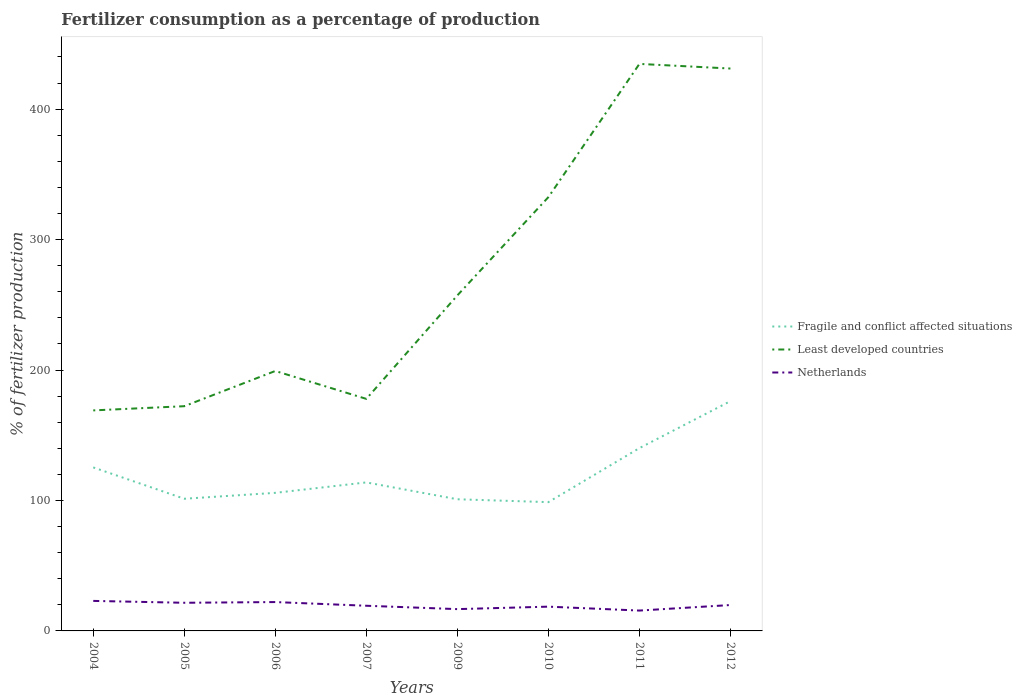Does the line corresponding to Least developed countries intersect with the line corresponding to Fragile and conflict affected situations?
Your answer should be compact. No. Is the number of lines equal to the number of legend labels?
Keep it short and to the point. Yes. Across all years, what is the maximum percentage of fertilizers consumed in Netherlands?
Give a very brief answer. 15.6. What is the total percentage of fertilizers consumed in Netherlands in the graph?
Offer a very short reply. -4.24. What is the difference between the highest and the second highest percentage of fertilizers consumed in Fragile and conflict affected situations?
Make the answer very short. 77.42. Is the percentage of fertilizers consumed in Fragile and conflict affected situations strictly greater than the percentage of fertilizers consumed in Netherlands over the years?
Provide a short and direct response. No. How many years are there in the graph?
Provide a short and direct response. 8. Does the graph contain grids?
Make the answer very short. No. Where does the legend appear in the graph?
Offer a very short reply. Center right. How many legend labels are there?
Keep it short and to the point. 3. How are the legend labels stacked?
Keep it short and to the point. Vertical. What is the title of the graph?
Make the answer very short. Fertilizer consumption as a percentage of production. Does "Norway" appear as one of the legend labels in the graph?
Your answer should be very brief. No. What is the label or title of the Y-axis?
Offer a terse response. % of fertilizer production. What is the % of fertilizer production of Fragile and conflict affected situations in 2004?
Give a very brief answer. 125.33. What is the % of fertilizer production of Least developed countries in 2004?
Give a very brief answer. 169.04. What is the % of fertilizer production of Netherlands in 2004?
Give a very brief answer. 23.01. What is the % of fertilizer production in Fragile and conflict affected situations in 2005?
Your answer should be very brief. 101.32. What is the % of fertilizer production of Least developed countries in 2005?
Ensure brevity in your answer.  172.25. What is the % of fertilizer production in Netherlands in 2005?
Give a very brief answer. 21.58. What is the % of fertilizer production of Fragile and conflict affected situations in 2006?
Keep it short and to the point. 105.84. What is the % of fertilizer production in Least developed countries in 2006?
Your response must be concise. 199.25. What is the % of fertilizer production in Netherlands in 2006?
Make the answer very short. 22.12. What is the % of fertilizer production of Fragile and conflict affected situations in 2007?
Your answer should be very brief. 113.84. What is the % of fertilizer production in Least developed countries in 2007?
Give a very brief answer. 177.87. What is the % of fertilizer production of Netherlands in 2007?
Offer a very short reply. 19.29. What is the % of fertilizer production of Fragile and conflict affected situations in 2009?
Ensure brevity in your answer.  100.93. What is the % of fertilizer production of Least developed countries in 2009?
Provide a short and direct response. 257.18. What is the % of fertilizer production in Netherlands in 2009?
Give a very brief answer. 16.71. What is the % of fertilizer production of Fragile and conflict affected situations in 2010?
Provide a succinct answer. 98.72. What is the % of fertilizer production in Least developed countries in 2010?
Your answer should be compact. 332.5. What is the % of fertilizer production in Netherlands in 2010?
Offer a very short reply. 18.6. What is the % of fertilizer production in Fragile and conflict affected situations in 2011?
Offer a very short reply. 140.13. What is the % of fertilizer production of Least developed countries in 2011?
Your answer should be very brief. 434.64. What is the % of fertilizer production of Netherlands in 2011?
Ensure brevity in your answer.  15.6. What is the % of fertilizer production in Fragile and conflict affected situations in 2012?
Your answer should be very brief. 176.14. What is the % of fertilizer production in Least developed countries in 2012?
Provide a succinct answer. 431.09. What is the % of fertilizer production of Netherlands in 2012?
Keep it short and to the point. 19.84. Across all years, what is the maximum % of fertilizer production in Fragile and conflict affected situations?
Provide a succinct answer. 176.14. Across all years, what is the maximum % of fertilizer production in Least developed countries?
Keep it short and to the point. 434.64. Across all years, what is the maximum % of fertilizer production of Netherlands?
Your response must be concise. 23.01. Across all years, what is the minimum % of fertilizer production of Fragile and conflict affected situations?
Your answer should be very brief. 98.72. Across all years, what is the minimum % of fertilizer production in Least developed countries?
Ensure brevity in your answer.  169.04. Across all years, what is the minimum % of fertilizer production in Netherlands?
Make the answer very short. 15.6. What is the total % of fertilizer production of Fragile and conflict affected situations in the graph?
Give a very brief answer. 962.24. What is the total % of fertilizer production of Least developed countries in the graph?
Ensure brevity in your answer.  2173.81. What is the total % of fertilizer production of Netherlands in the graph?
Provide a short and direct response. 156.76. What is the difference between the % of fertilizer production in Fragile and conflict affected situations in 2004 and that in 2005?
Make the answer very short. 24.02. What is the difference between the % of fertilizer production in Least developed countries in 2004 and that in 2005?
Provide a succinct answer. -3.22. What is the difference between the % of fertilizer production in Netherlands in 2004 and that in 2005?
Keep it short and to the point. 1.43. What is the difference between the % of fertilizer production of Fragile and conflict affected situations in 2004 and that in 2006?
Offer a very short reply. 19.5. What is the difference between the % of fertilizer production of Least developed countries in 2004 and that in 2006?
Offer a terse response. -30.21. What is the difference between the % of fertilizer production of Netherlands in 2004 and that in 2006?
Provide a succinct answer. 0.89. What is the difference between the % of fertilizer production in Fragile and conflict affected situations in 2004 and that in 2007?
Provide a short and direct response. 11.49. What is the difference between the % of fertilizer production in Least developed countries in 2004 and that in 2007?
Ensure brevity in your answer.  -8.83. What is the difference between the % of fertilizer production in Netherlands in 2004 and that in 2007?
Give a very brief answer. 3.71. What is the difference between the % of fertilizer production of Fragile and conflict affected situations in 2004 and that in 2009?
Offer a very short reply. 24.41. What is the difference between the % of fertilizer production of Least developed countries in 2004 and that in 2009?
Keep it short and to the point. -88.14. What is the difference between the % of fertilizer production in Netherlands in 2004 and that in 2009?
Provide a succinct answer. 6.3. What is the difference between the % of fertilizer production of Fragile and conflict affected situations in 2004 and that in 2010?
Provide a short and direct response. 26.61. What is the difference between the % of fertilizer production in Least developed countries in 2004 and that in 2010?
Give a very brief answer. -163.46. What is the difference between the % of fertilizer production of Netherlands in 2004 and that in 2010?
Provide a succinct answer. 4.41. What is the difference between the % of fertilizer production in Fragile and conflict affected situations in 2004 and that in 2011?
Your response must be concise. -14.8. What is the difference between the % of fertilizer production in Least developed countries in 2004 and that in 2011?
Offer a terse response. -265.6. What is the difference between the % of fertilizer production in Netherlands in 2004 and that in 2011?
Provide a succinct answer. 7.4. What is the difference between the % of fertilizer production in Fragile and conflict affected situations in 2004 and that in 2012?
Give a very brief answer. -50.8. What is the difference between the % of fertilizer production of Least developed countries in 2004 and that in 2012?
Make the answer very short. -262.05. What is the difference between the % of fertilizer production of Netherlands in 2004 and that in 2012?
Ensure brevity in your answer.  3.16. What is the difference between the % of fertilizer production of Fragile and conflict affected situations in 2005 and that in 2006?
Offer a very short reply. -4.52. What is the difference between the % of fertilizer production in Least developed countries in 2005 and that in 2006?
Your answer should be very brief. -27. What is the difference between the % of fertilizer production of Netherlands in 2005 and that in 2006?
Keep it short and to the point. -0.54. What is the difference between the % of fertilizer production in Fragile and conflict affected situations in 2005 and that in 2007?
Ensure brevity in your answer.  -12.53. What is the difference between the % of fertilizer production of Least developed countries in 2005 and that in 2007?
Your response must be concise. -5.62. What is the difference between the % of fertilizer production in Netherlands in 2005 and that in 2007?
Give a very brief answer. 2.28. What is the difference between the % of fertilizer production of Fragile and conflict affected situations in 2005 and that in 2009?
Make the answer very short. 0.39. What is the difference between the % of fertilizer production of Least developed countries in 2005 and that in 2009?
Offer a terse response. -84.93. What is the difference between the % of fertilizer production of Netherlands in 2005 and that in 2009?
Your response must be concise. 4.87. What is the difference between the % of fertilizer production in Fragile and conflict affected situations in 2005 and that in 2010?
Make the answer very short. 2.6. What is the difference between the % of fertilizer production in Least developed countries in 2005 and that in 2010?
Offer a very short reply. -160.24. What is the difference between the % of fertilizer production in Netherlands in 2005 and that in 2010?
Keep it short and to the point. 2.97. What is the difference between the % of fertilizer production in Fragile and conflict affected situations in 2005 and that in 2011?
Offer a very short reply. -38.81. What is the difference between the % of fertilizer production of Least developed countries in 2005 and that in 2011?
Provide a succinct answer. -262.38. What is the difference between the % of fertilizer production of Netherlands in 2005 and that in 2011?
Ensure brevity in your answer.  5.97. What is the difference between the % of fertilizer production in Fragile and conflict affected situations in 2005 and that in 2012?
Offer a very short reply. -74.82. What is the difference between the % of fertilizer production of Least developed countries in 2005 and that in 2012?
Make the answer very short. -258.83. What is the difference between the % of fertilizer production of Netherlands in 2005 and that in 2012?
Ensure brevity in your answer.  1.73. What is the difference between the % of fertilizer production of Fragile and conflict affected situations in 2006 and that in 2007?
Keep it short and to the point. -8. What is the difference between the % of fertilizer production in Least developed countries in 2006 and that in 2007?
Offer a very short reply. 21.38. What is the difference between the % of fertilizer production in Netherlands in 2006 and that in 2007?
Offer a very short reply. 2.83. What is the difference between the % of fertilizer production of Fragile and conflict affected situations in 2006 and that in 2009?
Make the answer very short. 4.91. What is the difference between the % of fertilizer production of Least developed countries in 2006 and that in 2009?
Offer a very short reply. -57.93. What is the difference between the % of fertilizer production of Netherlands in 2006 and that in 2009?
Provide a short and direct response. 5.41. What is the difference between the % of fertilizer production of Fragile and conflict affected situations in 2006 and that in 2010?
Your response must be concise. 7.12. What is the difference between the % of fertilizer production of Least developed countries in 2006 and that in 2010?
Keep it short and to the point. -133.25. What is the difference between the % of fertilizer production of Netherlands in 2006 and that in 2010?
Provide a succinct answer. 3.52. What is the difference between the % of fertilizer production in Fragile and conflict affected situations in 2006 and that in 2011?
Give a very brief answer. -34.29. What is the difference between the % of fertilizer production in Least developed countries in 2006 and that in 2011?
Make the answer very short. -235.39. What is the difference between the % of fertilizer production in Netherlands in 2006 and that in 2011?
Offer a terse response. 6.51. What is the difference between the % of fertilizer production of Fragile and conflict affected situations in 2006 and that in 2012?
Offer a terse response. -70.3. What is the difference between the % of fertilizer production in Least developed countries in 2006 and that in 2012?
Your answer should be very brief. -231.84. What is the difference between the % of fertilizer production of Netherlands in 2006 and that in 2012?
Your response must be concise. 2.28. What is the difference between the % of fertilizer production of Fragile and conflict affected situations in 2007 and that in 2009?
Your answer should be compact. 12.91. What is the difference between the % of fertilizer production in Least developed countries in 2007 and that in 2009?
Offer a very short reply. -79.31. What is the difference between the % of fertilizer production of Netherlands in 2007 and that in 2009?
Give a very brief answer. 2.58. What is the difference between the % of fertilizer production in Fragile and conflict affected situations in 2007 and that in 2010?
Ensure brevity in your answer.  15.12. What is the difference between the % of fertilizer production of Least developed countries in 2007 and that in 2010?
Keep it short and to the point. -154.63. What is the difference between the % of fertilizer production of Netherlands in 2007 and that in 2010?
Your answer should be very brief. 0.69. What is the difference between the % of fertilizer production in Fragile and conflict affected situations in 2007 and that in 2011?
Your response must be concise. -26.29. What is the difference between the % of fertilizer production in Least developed countries in 2007 and that in 2011?
Keep it short and to the point. -256.76. What is the difference between the % of fertilizer production in Netherlands in 2007 and that in 2011?
Give a very brief answer. 3.69. What is the difference between the % of fertilizer production in Fragile and conflict affected situations in 2007 and that in 2012?
Your answer should be compact. -62.29. What is the difference between the % of fertilizer production in Least developed countries in 2007 and that in 2012?
Offer a terse response. -253.22. What is the difference between the % of fertilizer production in Netherlands in 2007 and that in 2012?
Your answer should be very brief. -0.55. What is the difference between the % of fertilizer production of Fragile and conflict affected situations in 2009 and that in 2010?
Offer a terse response. 2.21. What is the difference between the % of fertilizer production of Least developed countries in 2009 and that in 2010?
Your response must be concise. -75.32. What is the difference between the % of fertilizer production in Netherlands in 2009 and that in 2010?
Offer a terse response. -1.89. What is the difference between the % of fertilizer production in Fragile and conflict affected situations in 2009 and that in 2011?
Give a very brief answer. -39.2. What is the difference between the % of fertilizer production of Least developed countries in 2009 and that in 2011?
Offer a terse response. -177.45. What is the difference between the % of fertilizer production of Netherlands in 2009 and that in 2011?
Give a very brief answer. 1.1. What is the difference between the % of fertilizer production in Fragile and conflict affected situations in 2009 and that in 2012?
Give a very brief answer. -75.21. What is the difference between the % of fertilizer production of Least developed countries in 2009 and that in 2012?
Ensure brevity in your answer.  -173.91. What is the difference between the % of fertilizer production in Netherlands in 2009 and that in 2012?
Provide a short and direct response. -3.14. What is the difference between the % of fertilizer production in Fragile and conflict affected situations in 2010 and that in 2011?
Provide a short and direct response. -41.41. What is the difference between the % of fertilizer production in Least developed countries in 2010 and that in 2011?
Provide a short and direct response. -102.14. What is the difference between the % of fertilizer production of Netherlands in 2010 and that in 2011?
Your answer should be compact. 3. What is the difference between the % of fertilizer production of Fragile and conflict affected situations in 2010 and that in 2012?
Ensure brevity in your answer.  -77.42. What is the difference between the % of fertilizer production in Least developed countries in 2010 and that in 2012?
Provide a succinct answer. -98.59. What is the difference between the % of fertilizer production in Netherlands in 2010 and that in 2012?
Your answer should be compact. -1.24. What is the difference between the % of fertilizer production in Fragile and conflict affected situations in 2011 and that in 2012?
Your answer should be very brief. -36.01. What is the difference between the % of fertilizer production of Least developed countries in 2011 and that in 2012?
Make the answer very short. 3.55. What is the difference between the % of fertilizer production in Netherlands in 2011 and that in 2012?
Your answer should be very brief. -4.24. What is the difference between the % of fertilizer production in Fragile and conflict affected situations in 2004 and the % of fertilizer production in Least developed countries in 2005?
Offer a terse response. -46.92. What is the difference between the % of fertilizer production in Fragile and conflict affected situations in 2004 and the % of fertilizer production in Netherlands in 2005?
Give a very brief answer. 103.76. What is the difference between the % of fertilizer production in Least developed countries in 2004 and the % of fertilizer production in Netherlands in 2005?
Provide a succinct answer. 147.46. What is the difference between the % of fertilizer production in Fragile and conflict affected situations in 2004 and the % of fertilizer production in Least developed countries in 2006?
Ensure brevity in your answer.  -73.92. What is the difference between the % of fertilizer production of Fragile and conflict affected situations in 2004 and the % of fertilizer production of Netherlands in 2006?
Your answer should be compact. 103.22. What is the difference between the % of fertilizer production of Least developed countries in 2004 and the % of fertilizer production of Netherlands in 2006?
Your response must be concise. 146.92. What is the difference between the % of fertilizer production of Fragile and conflict affected situations in 2004 and the % of fertilizer production of Least developed countries in 2007?
Provide a short and direct response. -52.54. What is the difference between the % of fertilizer production of Fragile and conflict affected situations in 2004 and the % of fertilizer production of Netherlands in 2007?
Give a very brief answer. 106.04. What is the difference between the % of fertilizer production of Least developed countries in 2004 and the % of fertilizer production of Netherlands in 2007?
Offer a very short reply. 149.74. What is the difference between the % of fertilizer production of Fragile and conflict affected situations in 2004 and the % of fertilizer production of Least developed countries in 2009?
Offer a terse response. -131.85. What is the difference between the % of fertilizer production in Fragile and conflict affected situations in 2004 and the % of fertilizer production in Netherlands in 2009?
Keep it short and to the point. 108.63. What is the difference between the % of fertilizer production of Least developed countries in 2004 and the % of fertilizer production of Netherlands in 2009?
Offer a very short reply. 152.33. What is the difference between the % of fertilizer production in Fragile and conflict affected situations in 2004 and the % of fertilizer production in Least developed countries in 2010?
Your response must be concise. -207.16. What is the difference between the % of fertilizer production in Fragile and conflict affected situations in 2004 and the % of fertilizer production in Netherlands in 2010?
Keep it short and to the point. 106.73. What is the difference between the % of fertilizer production of Least developed countries in 2004 and the % of fertilizer production of Netherlands in 2010?
Your answer should be compact. 150.44. What is the difference between the % of fertilizer production of Fragile and conflict affected situations in 2004 and the % of fertilizer production of Least developed countries in 2011?
Your response must be concise. -309.3. What is the difference between the % of fertilizer production of Fragile and conflict affected situations in 2004 and the % of fertilizer production of Netherlands in 2011?
Provide a short and direct response. 109.73. What is the difference between the % of fertilizer production in Least developed countries in 2004 and the % of fertilizer production in Netherlands in 2011?
Make the answer very short. 153.43. What is the difference between the % of fertilizer production of Fragile and conflict affected situations in 2004 and the % of fertilizer production of Least developed countries in 2012?
Your answer should be very brief. -305.75. What is the difference between the % of fertilizer production in Fragile and conflict affected situations in 2004 and the % of fertilizer production in Netherlands in 2012?
Give a very brief answer. 105.49. What is the difference between the % of fertilizer production in Least developed countries in 2004 and the % of fertilizer production in Netherlands in 2012?
Give a very brief answer. 149.19. What is the difference between the % of fertilizer production in Fragile and conflict affected situations in 2005 and the % of fertilizer production in Least developed countries in 2006?
Keep it short and to the point. -97.93. What is the difference between the % of fertilizer production of Fragile and conflict affected situations in 2005 and the % of fertilizer production of Netherlands in 2006?
Give a very brief answer. 79.2. What is the difference between the % of fertilizer production in Least developed countries in 2005 and the % of fertilizer production in Netherlands in 2006?
Offer a very short reply. 150.14. What is the difference between the % of fertilizer production of Fragile and conflict affected situations in 2005 and the % of fertilizer production of Least developed countries in 2007?
Give a very brief answer. -76.56. What is the difference between the % of fertilizer production of Fragile and conflict affected situations in 2005 and the % of fertilizer production of Netherlands in 2007?
Offer a very short reply. 82.02. What is the difference between the % of fertilizer production of Least developed countries in 2005 and the % of fertilizer production of Netherlands in 2007?
Your answer should be compact. 152.96. What is the difference between the % of fertilizer production in Fragile and conflict affected situations in 2005 and the % of fertilizer production in Least developed countries in 2009?
Keep it short and to the point. -155.87. What is the difference between the % of fertilizer production of Fragile and conflict affected situations in 2005 and the % of fertilizer production of Netherlands in 2009?
Provide a succinct answer. 84.61. What is the difference between the % of fertilizer production in Least developed countries in 2005 and the % of fertilizer production in Netherlands in 2009?
Your answer should be very brief. 155.55. What is the difference between the % of fertilizer production of Fragile and conflict affected situations in 2005 and the % of fertilizer production of Least developed countries in 2010?
Provide a succinct answer. -231.18. What is the difference between the % of fertilizer production in Fragile and conflict affected situations in 2005 and the % of fertilizer production in Netherlands in 2010?
Your answer should be compact. 82.71. What is the difference between the % of fertilizer production of Least developed countries in 2005 and the % of fertilizer production of Netherlands in 2010?
Offer a terse response. 153.65. What is the difference between the % of fertilizer production in Fragile and conflict affected situations in 2005 and the % of fertilizer production in Least developed countries in 2011?
Your answer should be compact. -333.32. What is the difference between the % of fertilizer production of Fragile and conflict affected situations in 2005 and the % of fertilizer production of Netherlands in 2011?
Provide a succinct answer. 85.71. What is the difference between the % of fertilizer production in Least developed countries in 2005 and the % of fertilizer production in Netherlands in 2011?
Make the answer very short. 156.65. What is the difference between the % of fertilizer production in Fragile and conflict affected situations in 2005 and the % of fertilizer production in Least developed countries in 2012?
Ensure brevity in your answer.  -329.77. What is the difference between the % of fertilizer production in Fragile and conflict affected situations in 2005 and the % of fertilizer production in Netherlands in 2012?
Your response must be concise. 81.47. What is the difference between the % of fertilizer production of Least developed countries in 2005 and the % of fertilizer production of Netherlands in 2012?
Ensure brevity in your answer.  152.41. What is the difference between the % of fertilizer production of Fragile and conflict affected situations in 2006 and the % of fertilizer production of Least developed countries in 2007?
Keep it short and to the point. -72.03. What is the difference between the % of fertilizer production in Fragile and conflict affected situations in 2006 and the % of fertilizer production in Netherlands in 2007?
Your response must be concise. 86.55. What is the difference between the % of fertilizer production in Least developed countries in 2006 and the % of fertilizer production in Netherlands in 2007?
Your answer should be compact. 179.96. What is the difference between the % of fertilizer production of Fragile and conflict affected situations in 2006 and the % of fertilizer production of Least developed countries in 2009?
Keep it short and to the point. -151.34. What is the difference between the % of fertilizer production in Fragile and conflict affected situations in 2006 and the % of fertilizer production in Netherlands in 2009?
Keep it short and to the point. 89.13. What is the difference between the % of fertilizer production of Least developed countries in 2006 and the % of fertilizer production of Netherlands in 2009?
Give a very brief answer. 182.54. What is the difference between the % of fertilizer production of Fragile and conflict affected situations in 2006 and the % of fertilizer production of Least developed countries in 2010?
Offer a terse response. -226.66. What is the difference between the % of fertilizer production in Fragile and conflict affected situations in 2006 and the % of fertilizer production in Netherlands in 2010?
Your response must be concise. 87.24. What is the difference between the % of fertilizer production in Least developed countries in 2006 and the % of fertilizer production in Netherlands in 2010?
Your answer should be very brief. 180.65. What is the difference between the % of fertilizer production in Fragile and conflict affected situations in 2006 and the % of fertilizer production in Least developed countries in 2011?
Offer a very short reply. -328.8. What is the difference between the % of fertilizer production in Fragile and conflict affected situations in 2006 and the % of fertilizer production in Netherlands in 2011?
Provide a short and direct response. 90.24. What is the difference between the % of fertilizer production of Least developed countries in 2006 and the % of fertilizer production of Netherlands in 2011?
Provide a succinct answer. 183.65. What is the difference between the % of fertilizer production in Fragile and conflict affected situations in 2006 and the % of fertilizer production in Least developed countries in 2012?
Your response must be concise. -325.25. What is the difference between the % of fertilizer production in Fragile and conflict affected situations in 2006 and the % of fertilizer production in Netherlands in 2012?
Give a very brief answer. 86. What is the difference between the % of fertilizer production in Least developed countries in 2006 and the % of fertilizer production in Netherlands in 2012?
Offer a terse response. 179.41. What is the difference between the % of fertilizer production of Fragile and conflict affected situations in 2007 and the % of fertilizer production of Least developed countries in 2009?
Provide a short and direct response. -143.34. What is the difference between the % of fertilizer production in Fragile and conflict affected situations in 2007 and the % of fertilizer production in Netherlands in 2009?
Ensure brevity in your answer.  97.13. What is the difference between the % of fertilizer production in Least developed countries in 2007 and the % of fertilizer production in Netherlands in 2009?
Provide a short and direct response. 161.16. What is the difference between the % of fertilizer production of Fragile and conflict affected situations in 2007 and the % of fertilizer production of Least developed countries in 2010?
Make the answer very short. -218.66. What is the difference between the % of fertilizer production in Fragile and conflict affected situations in 2007 and the % of fertilizer production in Netherlands in 2010?
Offer a terse response. 95.24. What is the difference between the % of fertilizer production in Least developed countries in 2007 and the % of fertilizer production in Netherlands in 2010?
Provide a short and direct response. 159.27. What is the difference between the % of fertilizer production in Fragile and conflict affected situations in 2007 and the % of fertilizer production in Least developed countries in 2011?
Provide a succinct answer. -320.79. What is the difference between the % of fertilizer production in Fragile and conflict affected situations in 2007 and the % of fertilizer production in Netherlands in 2011?
Your answer should be very brief. 98.24. What is the difference between the % of fertilizer production of Least developed countries in 2007 and the % of fertilizer production of Netherlands in 2011?
Your answer should be compact. 162.27. What is the difference between the % of fertilizer production in Fragile and conflict affected situations in 2007 and the % of fertilizer production in Least developed countries in 2012?
Your answer should be compact. -317.25. What is the difference between the % of fertilizer production of Fragile and conflict affected situations in 2007 and the % of fertilizer production of Netherlands in 2012?
Your answer should be very brief. 94. What is the difference between the % of fertilizer production of Least developed countries in 2007 and the % of fertilizer production of Netherlands in 2012?
Your answer should be compact. 158.03. What is the difference between the % of fertilizer production in Fragile and conflict affected situations in 2009 and the % of fertilizer production in Least developed countries in 2010?
Keep it short and to the point. -231.57. What is the difference between the % of fertilizer production in Fragile and conflict affected situations in 2009 and the % of fertilizer production in Netherlands in 2010?
Your answer should be compact. 82.33. What is the difference between the % of fertilizer production in Least developed countries in 2009 and the % of fertilizer production in Netherlands in 2010?
Provide a short and direct response. 238.58. What is the difference between the % of fertilizer production in Fragile and conflict affected situations in 2009 and the % of fertilizer production in Least developed countries in 2011?
Provide a short and direct response. -333.71. What is the difference between the % of fertilizer production in Fragile and conflict affected situations in 2009 and the % of fertilizer production in Netherlands in 2011?
Your answer should be compact. 85.32. What is the difference between the % of fertilizer production in Least developed countries in 2009 and the % of fertilizer production in Netherlands in 2011?
Offer a terse response. 241.58. What is the difference between the % of fertilizer production of Fragile and conflict affected situations in 2009 and the % of fertilizer production of Least developed countries in 2012?
Provide a succinct answer. -330.16. What is the difference between the % of fertilizer production of Fragile and conflict affected situations in 2009 and the % of fertilizer production of Netherlands in 2012?
Give a very brief answer. 81.08. What is the difference between the % of fertilizer production in Least developed countries in 2009 and the % of fertilizer production in Netherlands in 2012?
Offer a terse response. 237.34. What is the difference between the % of fertilizer production of Fragile and conflict affected situations in 2010 and the % of fertilizer production of Least developed countries in 2011?
Offer a very short reply. -335.91. What is the difference between the % of fertilizer production of Fragile and conflict affected situations in 2010 and the % of fertilizer production of Netherlands in 2011?
Provide a short and direct response. 83.12. What is the difference between the % of fertilizer production of Least developed countries in 2010 and the % of fertilizer production of Netherlands in 2011?
Your answer should be compact. 316.89. What is the difference between the % of fertilizer production in Fragile and conflict affected situations in 2010 and the % of fertilizer production in Least developed countries in 2012?
Ensure brevity in your answer.  -332.37. What is the difference between the % of fertilizer production in Fragile and conflict affected situations in 2010 and the % of fertilizer production in Netherlands in 2012?
Keep it short and to the point. 78.88. What is the difference between the % of fertilizer production of Least developed countries in 2010 and the % of fertilizer production of Netherlands in 2012?
Your response must be concise. 312.65. What is the difference between the % of fertilizer production of Fragile and conflict affected situations in 2011 and the % of fertilizer production of Least developed countries in 2012?
Your answer should be very brief. -290.96. What is the difference between the % of fertilizer production of Fragile and conflict affected situations in 2011 and the % of fertilizer production of Netherlands in 2012?
Provide a succinct answer. 120.29. What is the difference between the % of fertilizer production in Least developed countries in 2011 and the % of fertilizer production in Netherlands in 2012?
Keep it short and to the point. 414.79. What is the average % of fertilizer production in Fragile and conflict affected situations per year?
Provide a succinct answer. 120.28. What is the average % of fertilizer production of Least developed countries per year?
Offer a very short reply. 271.73. What is the average % of fertilizer production in Netherlands per year?
Your answer should be compact. 19.59. In the year 2004, what is the difference between the % of fertilizer production in Fragile and conflict affected situations and % of fertilizer production in Least developed countries?
Offer a terse response. -43.7. In the year 2004, what is the difference between the % of fertilizer production of Fragile and conflict affected situations and % of fertilizer production of Netherlands?
Provide a short and direct response. 102.33. In the year 2004, what is the difference between the % of fertilizer production in Least developed countries and % of fertilizer production in Netherlands?
Give a very brief answer. 146.03. In the year 2005, what is the difference between the % of fertilizer production of Fragile and conflict affected situations and % of fertilizer production of Least developed countries?
Your answer should be compact. -70.94. In the year 2005, what is the difference between the % of fertilizer production in Fragile and conflict affected situations and % of fertilizer production in Netherlands?
Your answer should be compact. 79.74. In the year 2005, what is the difference between the % of fertilizer production in Least developed countries and % of fertilizer production in Netherlands?
Provide a short and direct response. 150.68. In the year 2006, what is the difference between the % of fertilizer production in Fragile and conflict affected situations and % of fertilizer production in Least developed countries?
Offer a terse response. -93.41. In the year 2006, what is the difference between the % of fertilizer production of Fragile and conflict affected situations and % of fertilizer production of Netherlands?
Offer a very short reply. 83.72. In the year 2006, what is the difference between the % of fertilizer production of Least developed countries and % of fertilizer production of Netherlands?
Offer a very short reply. 177.13. In the year 2007, what is the difference between the % of fertilizer production in Fragile and conflict affected situations and % of fertilizer production in Least developed countries?
Ensure brevity in your answer.  -64.03. In the year 2007, what is the difference between the % of fertilizer production in Fragile and conflict affected situations and % of fertilizer production in Netherlands?
Your answer should be very brief. 94.55. In the year 2007, what is the difference between the % of fertilizer production in Least developed countries and % of fertilizer production in Netherlands?
Give a very brief answer. 158.58. In the year 2009, what is the difference between the % of fertilizer production of Fragile and conflict affected situations and % of fertilizer production of Least developed countries?
Offer a terse response. -156.25. In the year 2009, what is the difference between the % of fertilizer production of Fragile and conflict affected situations and % of fertilizer production of Netherlands?
Ensure brevity in your answer.  84.22. In the year 2009, what is the difference between the % of fertilizer production in Least developed countries and % of fertilizer production in Netherlands?
Give a very brief answer. 240.47. In the year 2010, what is the difference between the % of fertilizer production of Fragile and conflict affected situations and % of fertilizer production of Least developed countries?
Make the answer very short. -233.78. In the year 2010, what is the difference between the % of fertilizer production in Fragile and conflict affected situations and % of fertilizer production in Netherlands?
Make the answer very short. 80.12. In the year 2010, what is the difference between the % of fertilizer production of Least developed countries and % of fertilizer production of Netherlands?
Give a very brief answer. 313.89. In the year 2011, what is the difference between the % of fertilizer production of Fragile and conflict affected situations and % of fertilizer production of Least developed countries?
Your response must be concise. -294.51. In the year 2011, what is the difference between the % of fertilizer production of Fragile and conflict affected situations and % of fertilizer production of Netherlands?
Ensure brevity in your answer.  124.53. In the year 2011, what is the difference between the % of fertilizer production of Least developed countries and % of fertilizer production of Netherlands?
Your answer should be compact. 419.03. In the year 2012, what is the difference between the % of fertilizer production of Fragile and conflict affected situations and % of fertilizer production of Least developed countries?
Ensure brevity in your answer.  -254.95. In the year 2012, what is the difference between the % of fertilizer production of Fragile and conflict affected situations and % of fertilizer production of Netherlands?
Provide a short and direct response. 156.29. In the year 2012, what is the difference between the % of fertilizer production of Least developed countries and % of fertilizer production of Netherlands?
Ensure brevity in your answer.  411.24. What is the ratio of the % of fertilizer production in Fragile and conflict affected situations in 2004 to that in 2005?
Provide a succinct answer. 1.24. What is the ratio of the % of fertilizer production in Least developed countries in 2004 to that in 2005?
Keep it short and to the point. 0.98. What is the ratio of the % of fertilizer production in Netherlands in 2004 to that in 2005?
Provide a short and direct response. 1.07. What is the ratio of the % of fertilizer production of Fragile and conflict affected situations in 2004 to that in 2006?
Give a very brief answer. 1.18. What is the ratio of the % of fertilizer production in Least developed countries in 2004 to that in 2006?
Provide a short and direct response. 0.85. What is the ratio of the % of fertilizer production in Netherlands in 2004 to that in 2006?
Provide a short and direct response. 1.04. What is the ratio of the % of fertilizer production in Fragile and conflict affected situations in 2004 to that in 2007?
Your answer should be very brief. 1.1. What is the ratio of the % of fertilizer production in Least developed countries in 2004 to that in 2007?
Provide a short and direct response. 0.95. What is the ratio of the % of fertilizer production of Netherlands in 2004 to that in 2007?
Your answer should be very brief. 1.19. What is the ratio of the % of fertilizer production in Fragile and conflict affected situations in 2004 to that in 2009?
Give a very brief answer. 1.24. What is the ratio of the % of fertilizer production of Least developed countries in 2004 to that in 2009?
Your response must be concise. 0.66. What is the ratio of the % of fertilizer production in Netherlands in 2004 to that in 2009?
Make the answer very short. 1.38. What is the ratio of the % of fertilizer production of Fragile and conflict affected situations in 2004 to that in 2010?
Offer a very short reply. 1.27. What is the ratio of the % of fertilizer production of Least developed countries in 2004 to that in 2010?
Make the answer very short. 0.51. What is the ratio of the % of fertilizer production in Netherlands in 2004 to that in 2010?
Make the answer very short. 1.24. What is the ratio of the % of fertilizer production in Fragile and conflict affected situations in 2004 to that in 2011?
Make the answer very short. 0.89. What is the ratio of the % of fertilizer production in Least developed countries in 2004 to that in 2011?
Offer a terse response. 0.39. What is the ratio of the % of fertilizer production in Netherlands in 2004 to that in 2011?
Your response must be concise. 1.47. What is the ratio of the % of fertilizer production of Fragile and conflict affected situations in 2004 to that in 2012?
Give a very brief answer. 0.71. What is the ratio of the % of fertilizer production in Least developed countries in 2004 to that in 2012?
Offer a terse response. 0.39. What is the ratio of the % of fertilizer production in Netherlands in 2004 to that in 2012?
Offer a very short reply. 1.16. What is the ratio of the % of fertilizer production in Fragile and conflict affected situations in 2005 to that in 2006?
Your answer should be compact. 0.96. What is the ratio of the % of fertilizer production of Least developed countries in 2005 to that in 2006?
Ensure brevity in your answer.  0.86. What is the ratio of the % of fertilizer production in Netherlands in 2005 to that in 2006?
Offer a very short reply. 0.98. What is the ratio of the % of fertilizer production of Fragile and conflict affected situations in 2005 to that in 2007?
Make the answer very short. 0.89. What is the ratio of the % of fertilizer production of Least developed countries in 2005 to that in 2007?
Your answer should be very brief. 0.97. What is the ratio of the % of fertilizer production in Netherlands in 2005 to that in 2007?
Offer a terse response. 1.12. What is the ratio of the % of fertilizer production of Fragile and conflict affected situations in 2005 to that in 2009?
Ensure brevity in your answer.  1. What is the ratio of the % of fertilizer production in Least developed countries in 2005 to that in 2009?
Provide a short and direct response. 0.67. What is the ratio of the % of fertilizer production in Netherlands in 2005 to that in 2009?
Offer a terse response. 1.29. What is the ratio of the % of fertilizer production of Fragile and conflict affected situations in 2005 to that in 2010?
Make the answer very short. 1.03. What is the ratio of the % of fertilizer production of Least developed countries in 2005 to that in 2010?
Offer a terse response. 0.52. What is the ratio of the % of fertilizer production of Netherlands in 2005 to that in 2010?
Your answer should be very brief. 1.16. What is the ratio of the % of fertilizer production in Fragile and conflict affected situations in 2005 to that in 2011?
Ensure brevity in your answer.  0.72. What is the ratio of the % of fertilizer production of Least developed countries in 2005 to that in 2011?
Give a very brief answer. 0.4. What is the ratio of the % of fertilizer production in Netherlands in 2005 to that in 2011?
Make the answer very short. 1.38. What is the ratio of the % of fertilizer production of Fragile and conflict affected situations in 2005 to that in 2012?
Keep it short and to the point. 0.58. What is the ratio of the % of fertilizer production in Least developed countries in 2005 to that in 2012?
Provide a short and direct response. 0.4. What is the ratio of the % of fertilizer production of Netherlands in 2005 to that in 2012?
Your response must be concise. 1.09. What is the ratio of the % of fertilizer production in Fragile and conflict affected situations in 2006 to that in 2007?
Provide a succinct answer. 0.93. What is the ratio of the % of fertilizer production of Least developed countries in 2006 to that in 2007?
Ensure brevity in your answer.  1.12. What is the ratio of the % of fertilizer production of Netherlands in 2006 to that in 2007?
Ensure brevity in your answer.  1.15. What is the ratio of the % of fertilizer production in Fragile and conflict affected situations in 2006 to that in 2009?
Offer a very short reply. 1.05. What is the ratio of the % of fertilizer production of Least developed countries in 2006 to that in 2009?
Offer a very short reply. 0.77. What is the ratio of the % of fertilizer production of Netherlands in 2006 to that in 2009?
Provide a succinct answer. 1.32. What is the ratio of the % of fertilizer production in Fragile and conflict affected situations in 2006 to that in 2010?
Give a very brief answer. 1.07. What is the ratio of the % of fertilizer production of Least developed countries in 2006 to that in 2010?
Offer a terse response. 0.6. What is the ratio of the % of fertilizer production of Netherlands in 2006 to that in 2010?
Keep it short and to the point. 1.19. What is the ratio of the % of fertilizer production in Fragile and conflict affected situations in 2006 to that in 2011?
Provide a succinct answer. 0.76. What is the ratio of the % of fertilizer production of Least developed countries in 2006 to that in 2011?
Give a very brief answer. 0.46. What is the ratio of the % of fertilizer production of Netherlands in 2006 to that in 2011?
Provide a short and direct response. 1.42. What is the ratio of the % of fertilizer production in Fragile and conflict affected situations in 2006 to that in 2012?
Your answer should be very brief. 0.6. What is the ratio of the % of fertilizer production in Least developed countries in 2006 to that in 2012?
Keep it short and to the point. 0.46. What is the ratio of the % of fertilizer production of Netherlands in 2006 to that in 2012?
Ensure brevity in your answer.  1.11. What is the ratio of the % of fertilizer production in Fragile and conflict affected situations in 2007 to that in 2009?
Keep it short and to the point. 1.13. What is the ratio of the % of fertilizer production of Least developed countries in 2007 to that in 2009?
Ensure brevity in your answer.  0.69. What is the ratio of the % of fertilizer production in Netherlands in 2007 to that in 2009?
Make the answer very short. 1.15. What is the ratio of the % of fertilizer production of Fragile and conflict affected situations in 2007 to that in 2010?
Offer a terse response. 1.15. What is the ratio of the % of fertilizer production of Least developed countries in 2007 to that in 2010?
Provide a succinct answer. 0.54. What is the ratio of the % of fertilizer production in Netherlands in 2007 to that in 2010?
Provide a succinct answer. 1.04. What is the ratio of the % of fertilizer production of Fragile and conflict affected situations in 2007 to that in 2011?
Provide a short and direct response. 0.81. What is the ratio of the % of fertilizer production in Least developed countries in 2007 to that in 2011?
Offer a very short reply. 0.41. What is the ratio of the % of fertilizer production of Netherlands in 2007 to that in 2011?
Keep it short and to the point. 1.24. What is the ratio of the % of fertilizer production of Fragile and conflict affected situations in 2007 to that in 2012?
Your response must be concise. 0.65. What is the ratio of the % of fertilizer production of Least developed countries in 2007 to that in 2012?
Your response must be concise. 0.41. What is the ratio of the % of fertilizer production of Netherlands in 2007 to that in 2012?
Provide a succinct answer. 0.97. What is the ratio of the % of fertilizer production in Fragile and conflict affected situations in 2009 to that in 2010?
Give a very brief answer. 1.02. What is the ratio of the % of fertilizer production in Least developed countries in 2009 to that in 2010?
Ensure brevity in your answer.  0.77. What is the ratio of the % of fertilizer production of Netherlands in 2009 to that in 2010?
Ensure brevity in your answer.  0.9. What is the ratio of the % of fertilizer production in Fragile and conflict affected situations in 2009 to that in 2011?
Provide a short and direct response. 0.72. What is the ratio of the % of fertilizer production of Least developed countries in 2009 to that in 2011?
Provide a short and direct response. 0.59. What is the ratio of the % of fertilizer production of Netherlands in 2009 to that in 2011?
Keep it short and to the point. 1.07. What is the ratio of the % of fertilizer production of Fragile and conflict affected situations in 2009 to that in 2012?
Your answer should be compact. 0.57. What is the ratio of the % of fertilizer production in Least developed countries in 2009 to that in 2012?
Your response must be concise. 0.6. What is the ratio of the % of fertilizer production of Netherlands in 2009 to that in 2012?
Ensure brevity in your answer.  0.84. What is the ratio of the % of fertilizer production of Fragile and conflict affected situations in 2010 to that in 2011?
Your response must be concise. 0.7. What is the ratio of the % of fertilizer production of Least developed countries in 2010 to that in 2011?
Offer a terse response. 0.77. What is the ratio of the % of fertilizer production in Netherlands in 2010 to that in 2011?
Provide a short and direct response. 1.19. What is the ratio of the % of fertilizer production of Fragile and conflict affected situations in 2010 to that in 2012?
Give a very brief answer. 0.56. What is the ratio of the % of fertilizer production in Least developed countries in 2010 to that in 2012?
Give a very brief answer. 0.77. What is the ratio of the % of fertilizer production of Fragile and conflict affected situations in 2011 to that in 2012?
Provide a succinct answer. 0.8. What is the ratio of the % of fertilizer production in Least developed countries in 2011 to that in 2012?
Provide a short and direct response. 1.01. What is the ratio of the % of fertilizer production in Netherlands in 2011 to that in 2012?
Your response must be concise. 0.79. What is the difference between the highest and the second highest % of fertilizer production in Fragile and conflict affected situations?
Keep it short and to the point. 36.01. What is the difference between the highest and the second highest % of fertilizer production in Least developed countries?
Provide a short and direct response. 3.55. What is the difference between the highest and the second highest % of fertilizer production of Netherlands?
Your response must be concise. 0.89. What is the difference between the highest and the lowest % of fertilizer production of Fragile and conflict affected situations?
Your response must be concise. 77.42. What is the difference between the highest and the lowest % of fertilizer production in Least developed countries?
Your response must be concise. 265.6. What is the difference between the highest and the lowest % of fertilizer production in Netherlands?
Offer a very short reply. 7.4. 